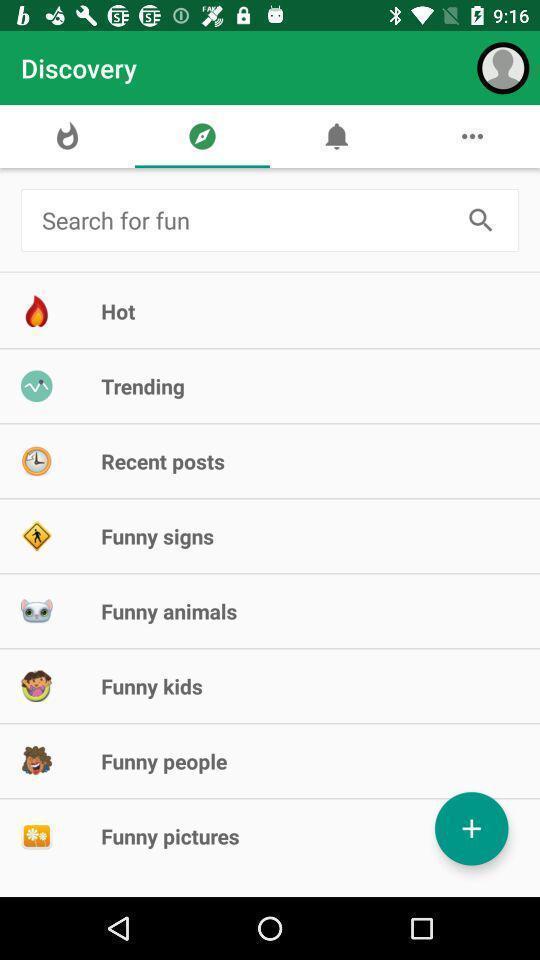Describe the key features of this screenshot. Search bar to search for the fun activities. 